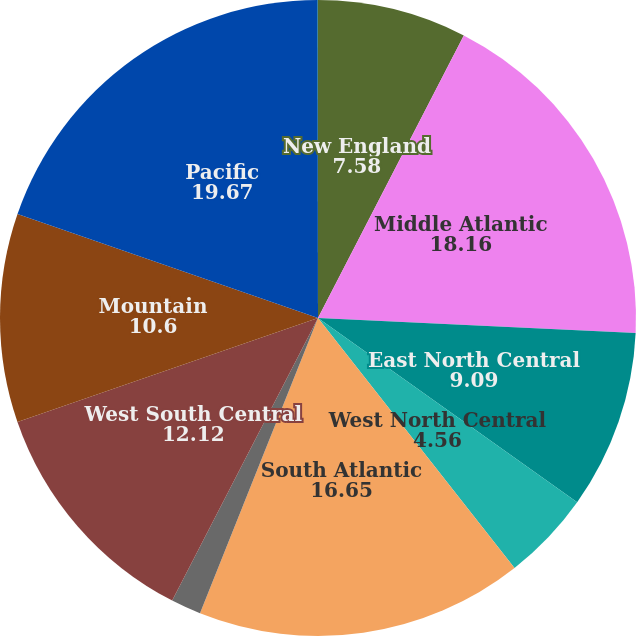Convert chart to OTSL. <chart><loc_0><loc_0><loc_500><loc_500><pie_chart><fcel>New England<fcel>Middle Atlantic<fcel>East North Central<fcel>West North Central<fcel>South Atlantic<fcel>East South Central<fcel>West South Central<fcel>Mountain<fcel>Pacific<fcel>International<nl><fcel>7.58%<fcel>18.16%<fcel>9.09%<fcel>4.56%<fcel>16.65%<fcel>1.53%<fcel>12.12%<fcel>10.6%<fcel>19.67%<fcel>0.02%<nl></chart> 